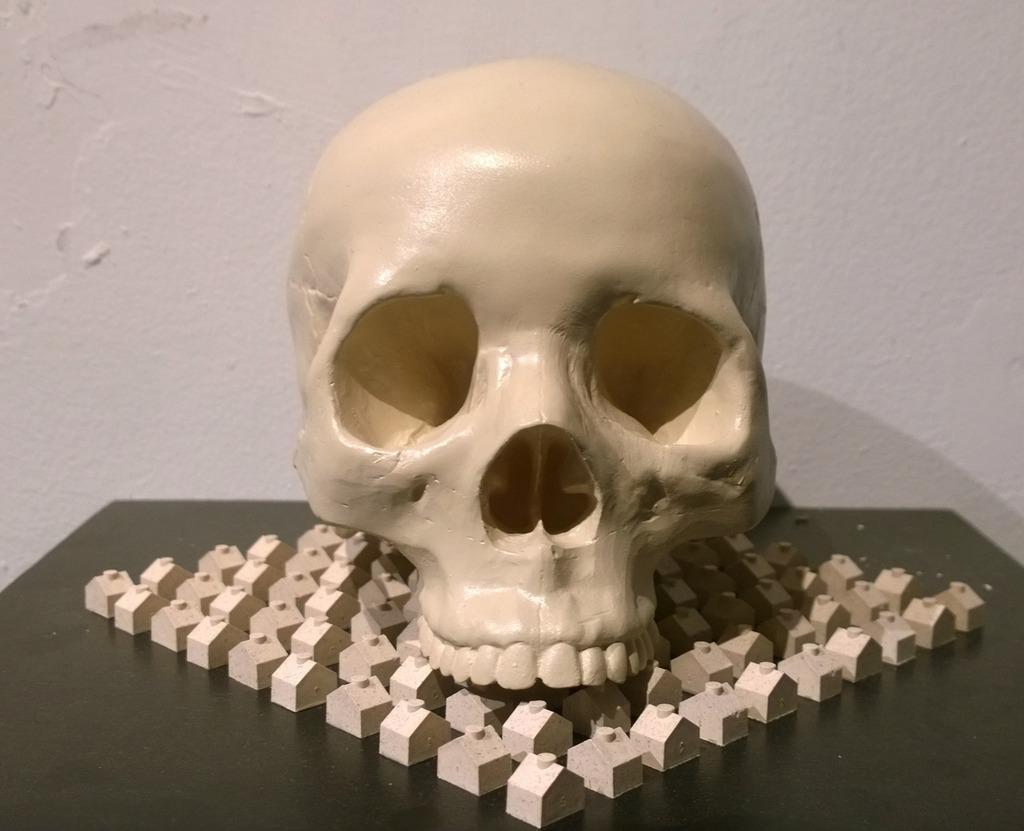How would you summarize this image in a sentence or two? In this image we can see a skull and some blocks on the table, in the background we can see the wall. 